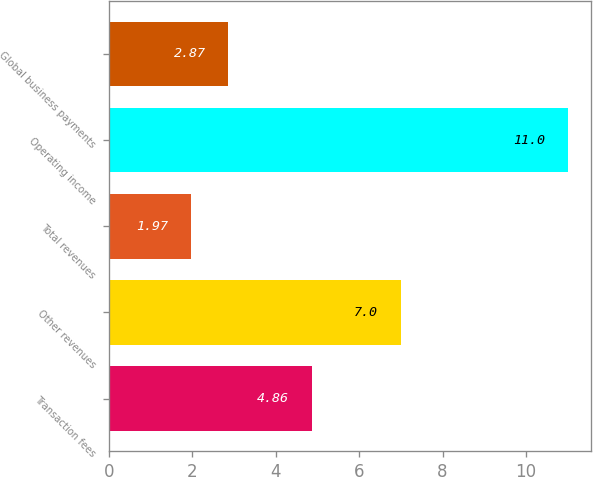Convert chart to OTSL. <chart><loc_0><loc_0><loc_500><loc_500><bar_chart><fcel>Transaction fees<fcel>Other revenues<fcel>Total revenues<fcel>Operating income<fcel>Global business payments<nl><fcel>4.86<fcel>7<fcel>1.97<fcel>11<fcel>2.87<nl></chart> 